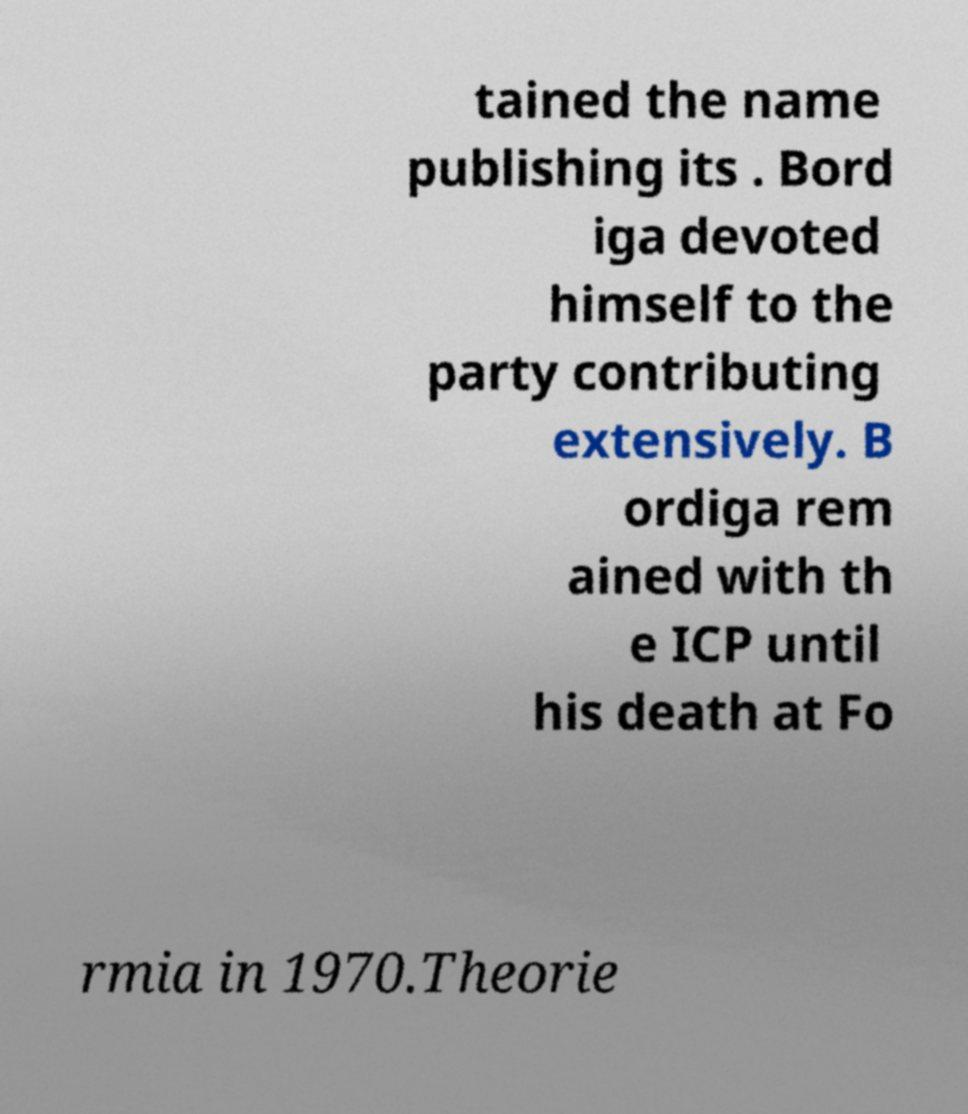Could you assist in decoding the text presented in this image and type it out clearly? tained the name publishing its . Bord iga devoted himself to the party contributing extensively. B ordiga rem ained with th e ICP until his death at Fo rmia in 1970.Theorie 